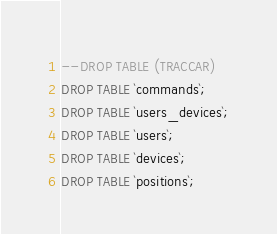Convert code to text. <code><loc_0><loc_0><loc_500><loc_500><_SQL_>--DROP TABLE (TRACCAR)
DROP TABLE `commands`;
DROP TABLE `users_devices`;
DROP TABLE `users`;
DROP TABLE `devices`;
DROP TABLE `positions`;</code> 